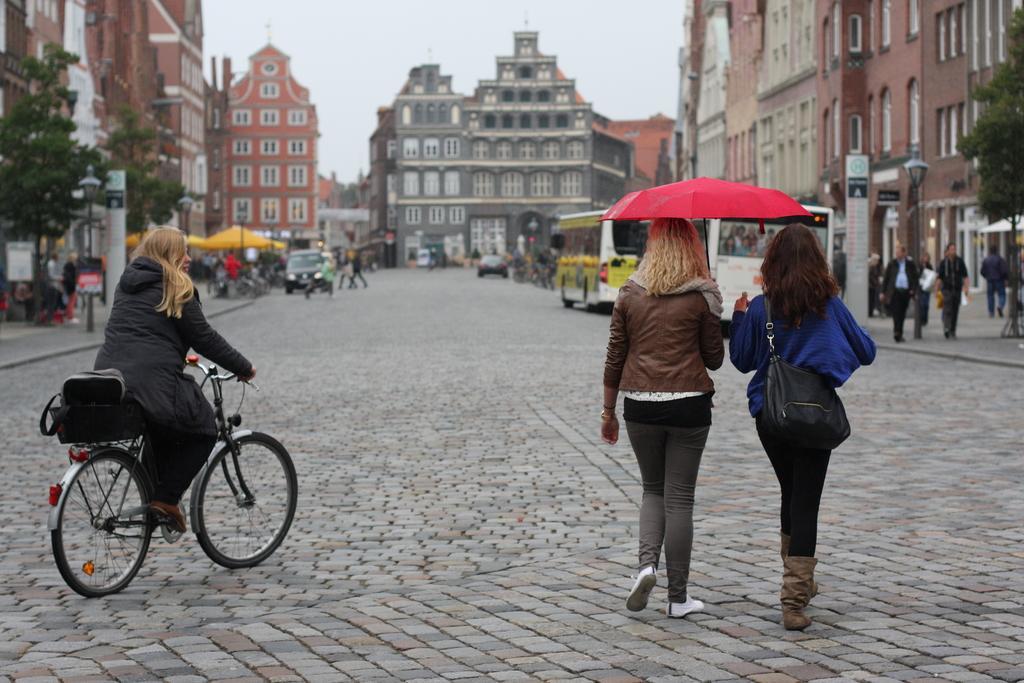In one or two sentences, can you explain what this image depicts? In the foreground of this image, there are two women where a woman is wearing a bag and another one is holding an umbrella are walking on the pavement and also a woman is riding a bicycle. In the background, there are buildings, trees, poles, boards, vehicles moving on the road, tents and the sky. 